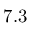<formula> <loc_0><loc_0><loc_500><loc_500>7 . 3</formula> 